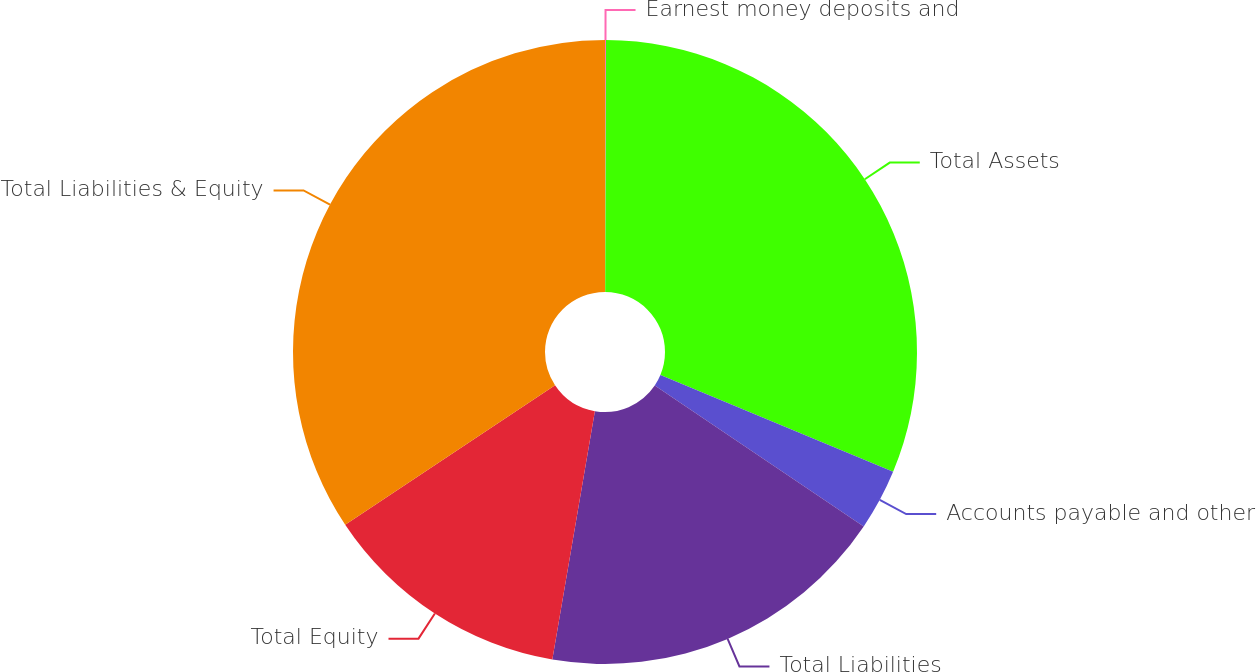Convert chart to OTSL. <chart><loc_0><loc_0><loc_500><loc_500><pie_chart><fcel>Earnest money deposits and<fcel>Total Assets<fcel>Accounts payable and other<fcel>Total Liabilities<fcel>Total Equity<fcel>Total Liabilities & Equity<nl><fcel>0.05%<fcel>31.22%<fcel>3.17%<fcel>18.26%<fcel>12.96%<fcel>34.34%<nl></chart> 